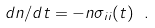<formula> <loc_0><loc_0><loc_500><loc_500>d n / d t = - n \sigma _ { i i } ( t ) \ .</formula> 